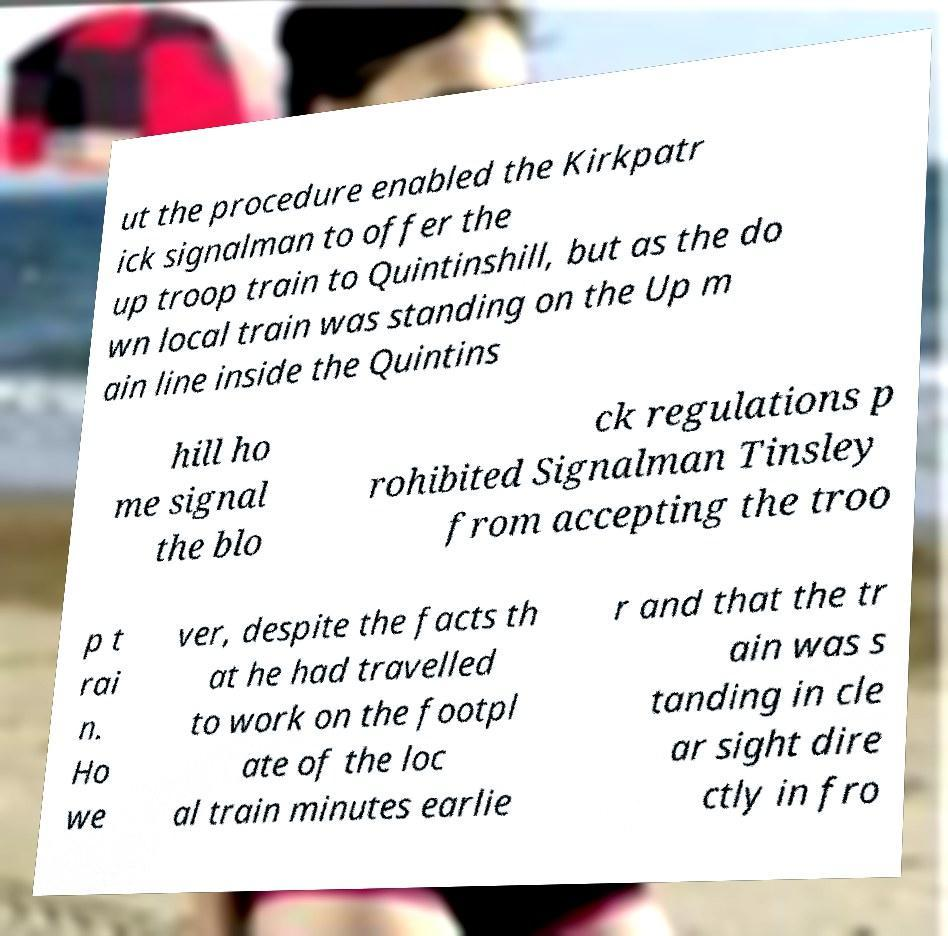Can you read and provide the text displayed in the image?This photo seems to have some interesting text. Can you extract and type it out for me? ut the procedure enabled the Kirkpatr ick signalman to offer the up troop train to Quintinshill, but as the do wn local train was standing on the Up m ain line inside the Quintins hill ho me signal the blo ck regulations p rohibited Signalman Tinsley from accepting the troo p t rai n. Ho we ver, despite the facts th at he had travelled to work on the footpl ate of the loc al train minutes earlie r and that the tr ain was s tanding in cle ar sight dire ctly in fro 